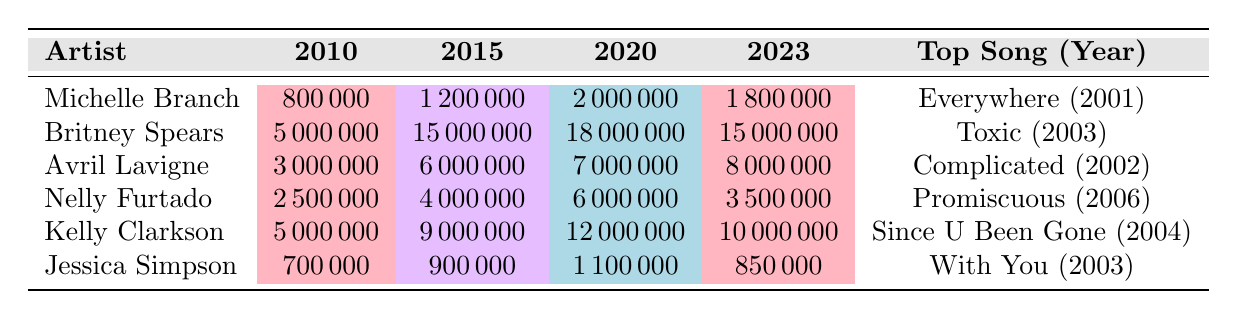What was the monthly listener count for Michelle Branch in 2015? According to the table, the monthly listener count for Michelle Branch in 2015 is listed as 1,200,000.
Answer: 1,200,000 Which artist had the highest number of monthly listeners in 2020? The table shows that Britney Spears had the highest number of monthly listeners in 2020, with a total of 18,000,000.
Answer: Britney Spears What is the difference in monthly listeners for Avril Lavigne between 2010 and 2023? For Avril Lavigne, the monthly listeners in 2010 was 3,000,000 and in 2023 it was 8,000,000. The difference is calculated as 8,000,000 - 3,000,000 = 5,000,000.
Answer: 5,000,000 Did Jessica Simpson have more monthly listeners in 2020 than Nelly Furtado? Looking at the figures, Jessica Simpson had 1,100,000 monthly listeners in 2020 while Nelly Furtado had 6,000,000. Since 1,100,000 is less than 6,000,000, the answer is no.
Answer: No What is the average number of monthly listeners across all artists in 2023? To find the average for 2023, we need to total the monthly listeners for all artists and then divide by the number of artists. The monthly listeners are: 1,800,000 (Michelle Branch) + 15,000,000 (Britney Spears) + 8,000,000 (Avril Lavigne) + 3,500,000 (Nelly Furtado) + 10,000,000 (Kelly Clarkson) + 850,000 (Jessica Simpson) = 39,150,000. Dividing by 6 gives an average of 6,525,000.
Answer: 6,525,000 